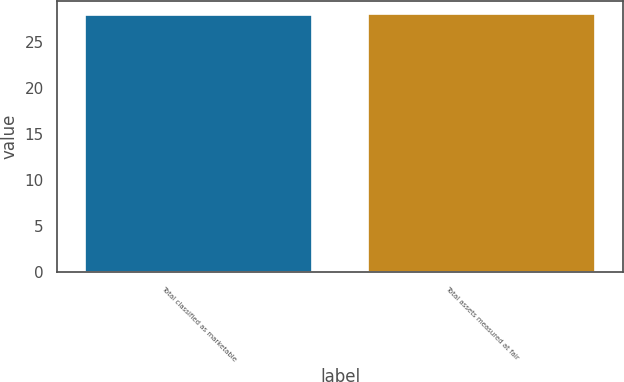Convert chart to OTSL. <chart><loc_0><loc_0><loc_500><loc_500><bar_chart><fcel>Total classified as marketable<fcel>Total assets measured at fair<nl><fcel>28<fcel>28.1<nl></chart> 